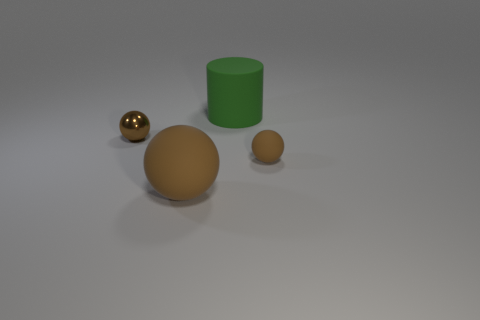Subtract all brown spheres. How many were subtracted if there are2brown spheres left? 1 Add 2 big green matte objects. How many objects exist? 6 Subtract all cylinders. How many objects are left? 3 Add 2 small matte objects. How many small matte objects are left? 3 Add 2 large brown things. How many large brown things exist? 3 Subtract 0 cyan cubes. How many objects are left? 4 Subtract all tiny gray metal cubes. Subtract all big brown things. How many objects are left? 3 